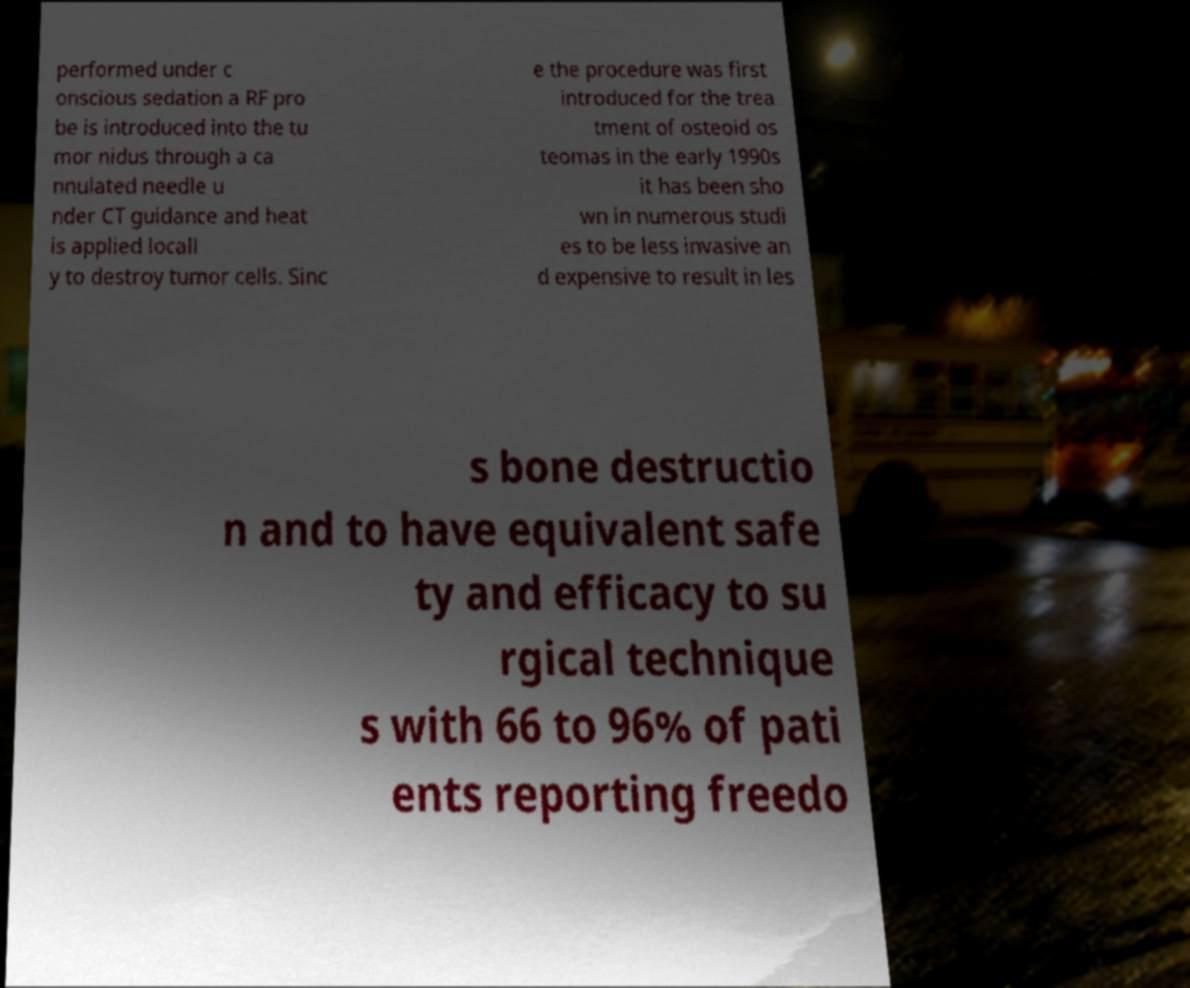What messages or text are displayed in this image? I need them in a readable, typed format. performed under c onscious sedation a RF pro be is introduced into the tu mor nidus through a ca nnulated needle u nder CT guidance and heat is applied locall y to destroy tumor cells. Sinc e the procedure was first introduced for the trea tment of osteoid os teomas in the early 1990s it has been sho wn in numerous studi es to be less invasive an d expensive to result in les s bone destructio n and to have equivalent safe ty and efficacy to su rgical technique s with 66 to 96% of pati ents reporting freedo 